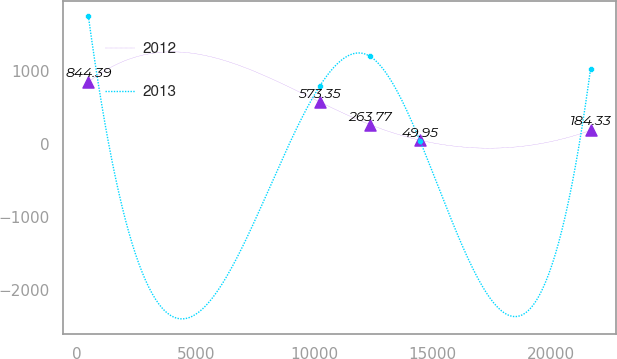Convert chart to OTSL. <chart><loc_0><loc_0><loc_500><loc_500><line_chart><ecel><fcel>2012<fcel>2013<nl><fcel>475.21<fcel>844.39<fcel>1744.92<nl><fcel>10225.4<fcel>573.35<fcel>786.05<nl><fcel>12343.1<fcel>263.77<fcel>1197.16<nl><fcel>14460.8<fcel>49.95<fcel>40.18<nl><fcel>21652.6<fcel>184.33<fcel>1026.69<nl></chart> 